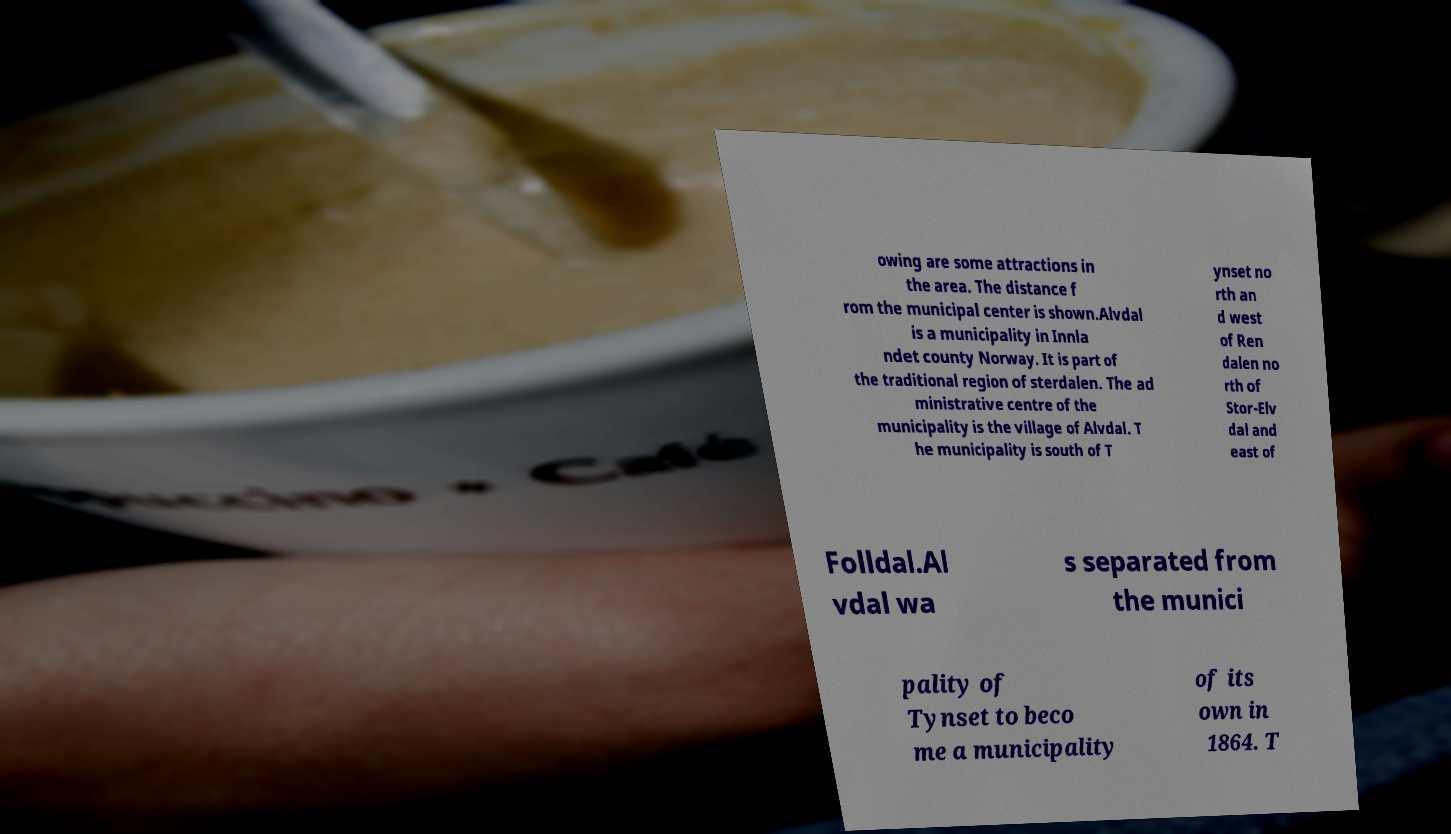Could you extract and type out the text from this image? owing are some attractions in the area. The distance f rom the municipal center is shown.Alvdal is a municipality in Innla ndet county Norway. It is part of the traditional region of sterdalen. The ad ministrative centre of the municipality is the village of Alvdal. T he municipality is south of T ynset no rth an d west of Ren dalen no rth of Stor-Elv dal and east of Folldal.Al vdal wa s separated from the munici pality of Tynset to beco me a municipality of its own in 1864. T 